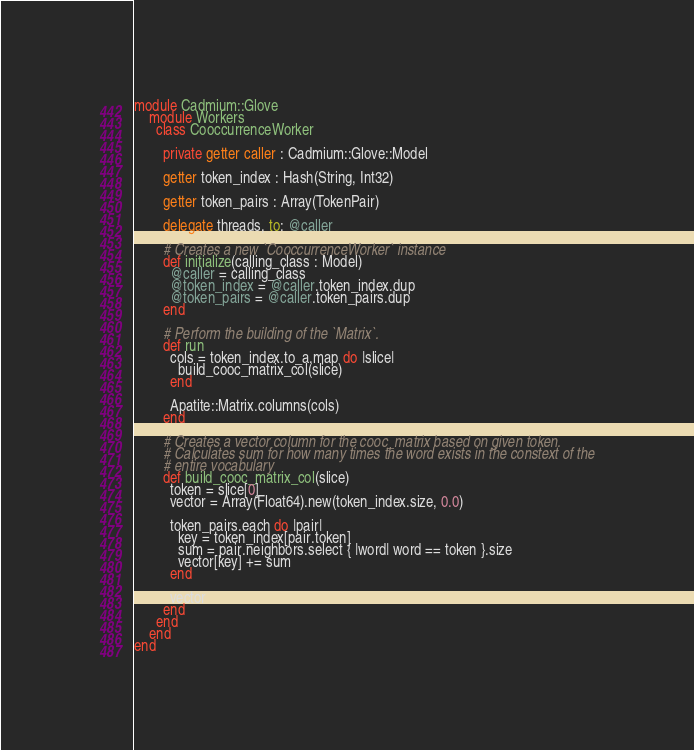Convert code to text. <code><loc_0><loc_0><loc_500><loc_500><_Crystal_>
module Cadmium::Glove
    module Workers
      class CooccurrenceWorker

        private getter caller : Cadmium::Glove::Model

        getter token_index : Hash(String, Int32)

        getter token_pairs : Array(TokenPair)

        delegate threads, to: @caller

        # Creates a new `CooccurrenceWorker` instance
        def initialize(calling_class : Model)
          @caller = calling_class
          @token_index = @caller.token_index.dup
          @token_pairs = @caller.token_pairs.dup
        end

        # Perform the building of the `Matrix`.
        def run
          cols = token_index.to_a.map do |slice|
            build_cooc_matrix_col(slice)
          end

          Apatite::Matrix.columns(cols)
        end

        # Creates a vector column for the cooc_matrix based on given token.
        # Calculates sum for how many times the word exists in the constext of the
        # entire vocabulary
        def build_cooc_matrix_col(slice)
          token = slice[0]
          vector = Array(Float64).new(token_index.size, 0.0)

          token_pairs.each do |pair|
            key = token_index[pair.token]
            sum = pair.neighbors.select { |word| word == token }.size
            vector[key] += sum
          end

          vector
        end
      end
    end
end
</code> 